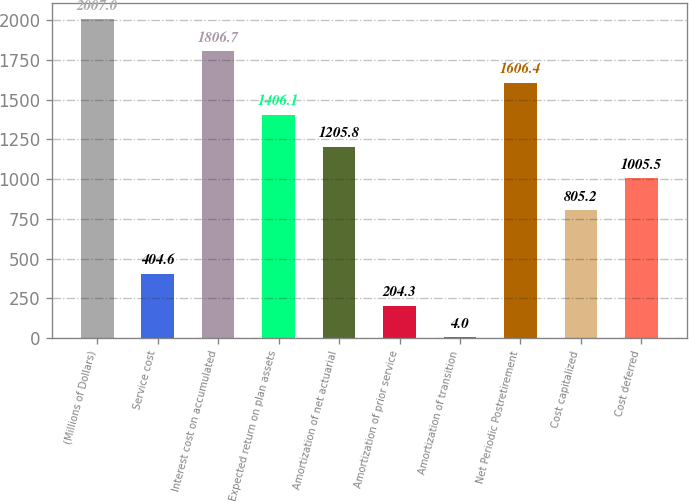<chart> <loc_0><loc_0><loc_500><loc_500><bar_chart><fcel>(Millions of Dollars)<fcel>Service cost<fcel>Interest cost on accumulated<fcel>Expected return on plan assets<fcel>Amortization of net actuarial<fcel>Amortization of prior service<fcel>Amortization of transition<fcel>Net Periodic Postretirement<fcel>Cost capitalized<fcel>Cost deferred<nl><fcel>2007<fcel>404.6<fcel>1806.7<fcel>1406.1<fcel>1205.8<fcel>204.3<fcel>4<fcel>1606.4<fcel>805.2<fcel>1005.5<nl></chart> 